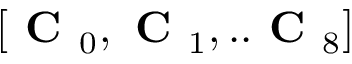Convert formula to latex. <formula><loc_0><loc_0><loc_500><loc_500>[ C _ { 0 } , C _ { 1 } , . . C _ { 8 } ]</formula> 